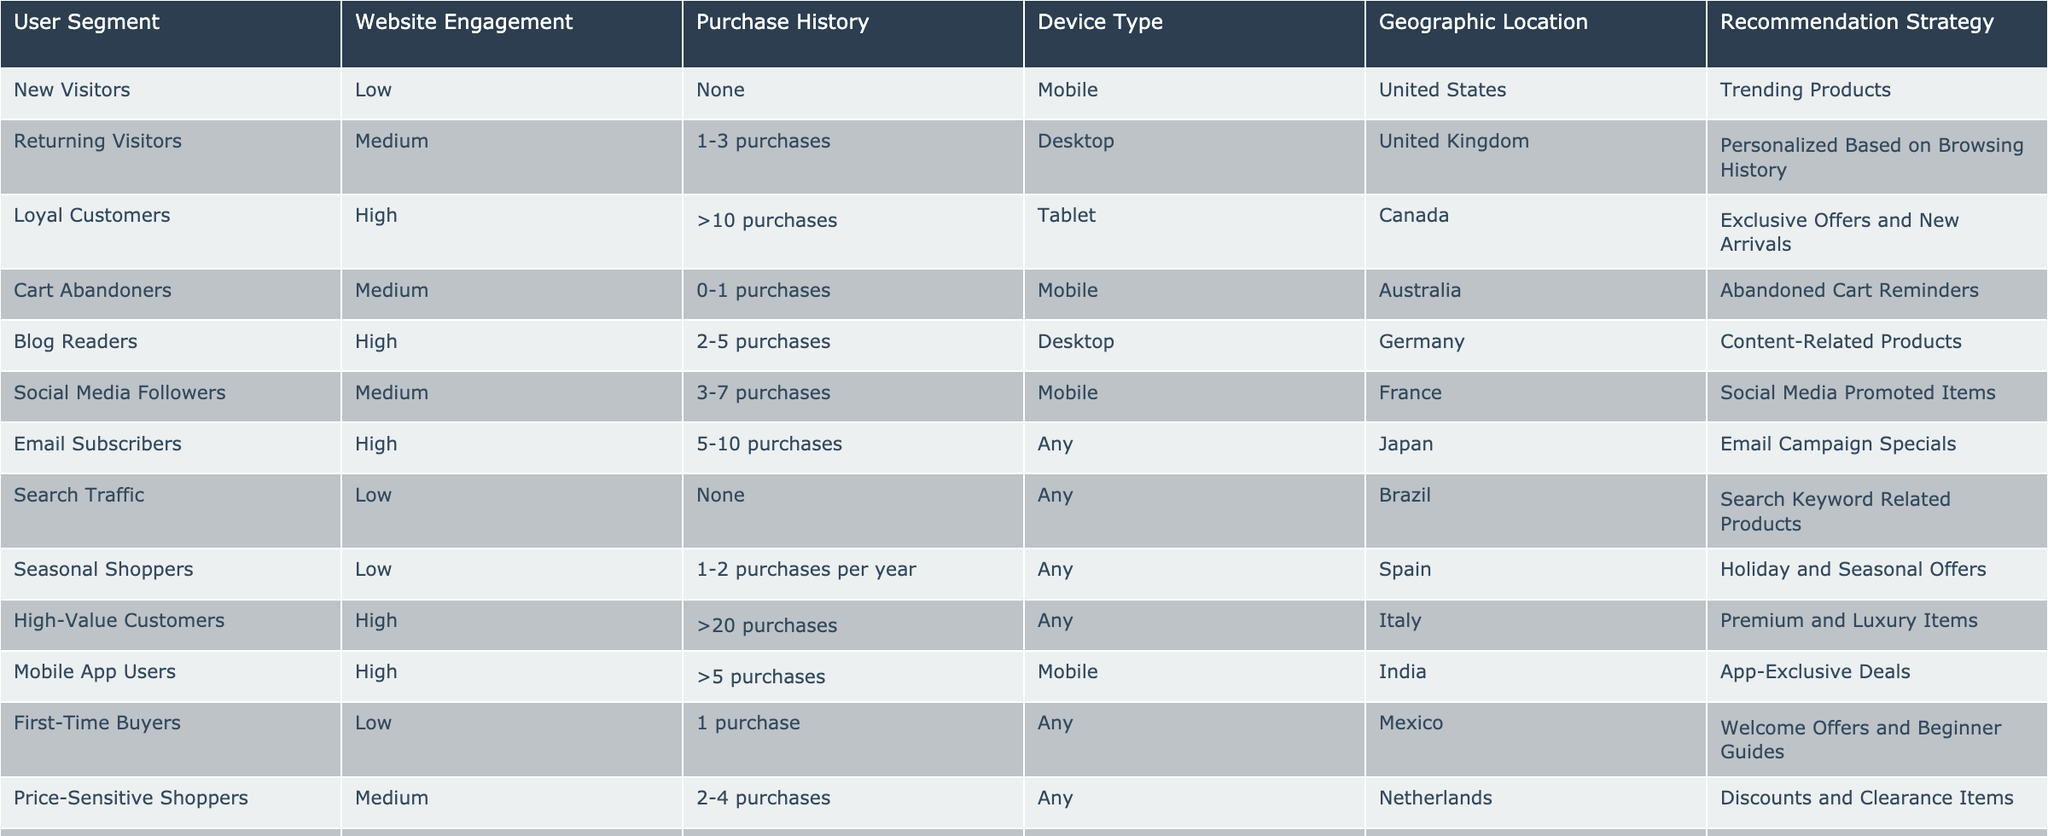What is the recommendation strategy for New Visitors? According to the table, New Visitors with low website engagement and no purchase history are recommended trending products.
Answer: Trending Products How many purchases do Loyal Customers typically have? The table indicates that Loyal Customers have more than 10 purchases in their purchase history.
Answer: More than 10 purchases Which device type is associated with Seasonal Shoppers? Seasonal Shoppers can use any device type as indicated in the table.
Answer: Any Are Cart Abandoners provided with personalized recommendations based on their browsing history? The table specifies that Cart Abandoners receive abandoned cart reminders, not personalized recommendations based on browsing history.
Answer: No What specific recommendation strategy applies to Email Subscribers? For Email Subscribers, the recommendation strategy listed in the table is Email Campaign Specials.
Answer: Email Campaign Specials Which user segment has the highest engagement and what is their recommendation strategy? The user segment with the highest engagement is High-Value Customers, who are offered premium and luxury items as their recommendation strategy.
Answer: High-Value Customers; Premium and Luxury Items How many user segments are associated with a Mobile device? By counting the rows in the table, 4 segments (New Visitors, Cart Abandoners, Social Media Followers, and Mobile App Users) are associated with the Mobile device.
Answer: 4 segments What is the difference in the number of purchases between High-Value Customers and First-Time Buyers? High-Value Customers have more than 20 purchases, whereas First-Time Buyers have typically 1 purchase. The difference is greater than 19 purchases.
Answer: Greater than 19 purchases Which user segment is likely to receive discounts and clearance items? The segmentation for Price-Sensitive Shoppers is associated with discounts and clearance items as indicated in the table.
Answer: Price-Sensitive Shoppers 